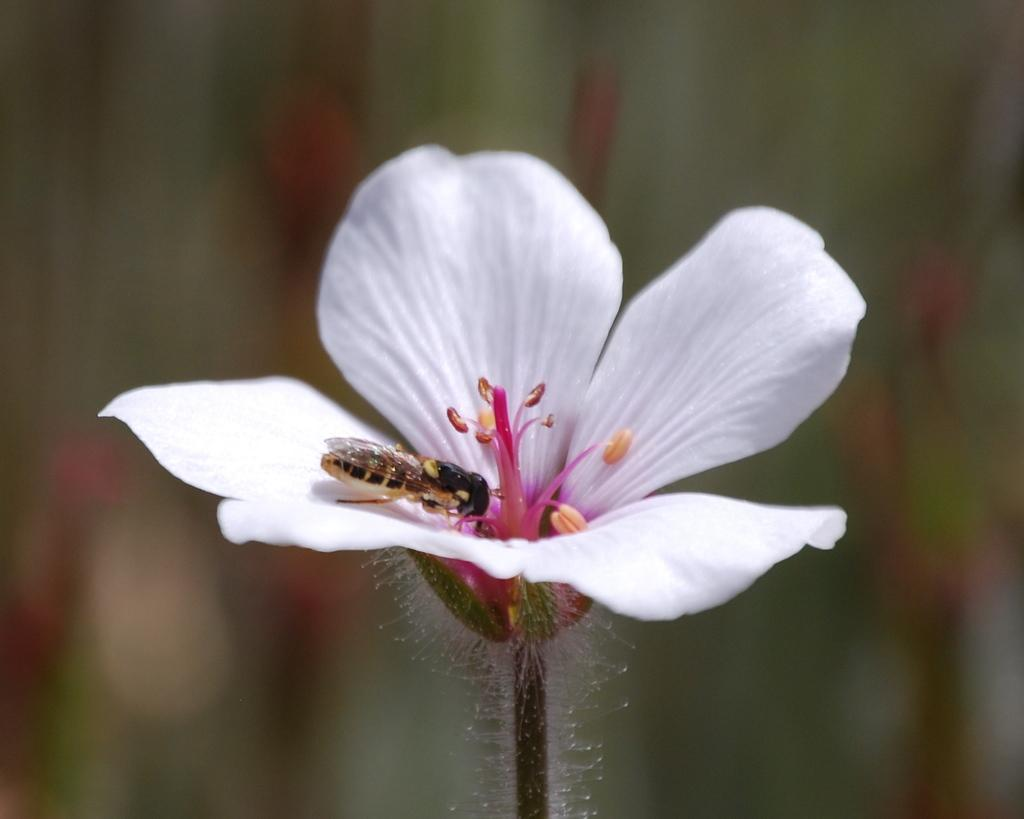What is the main subject of the image? There is a flower in the image. Is there anything else on the flower? Yes, there is an insect on the flower. Can you describe the background of the image? The background of the image is blurry. What type of spark can be seen coming from the base of the flower in the image? There is no spark present in the image; it features a flower with an insect on it and a blurry background. 